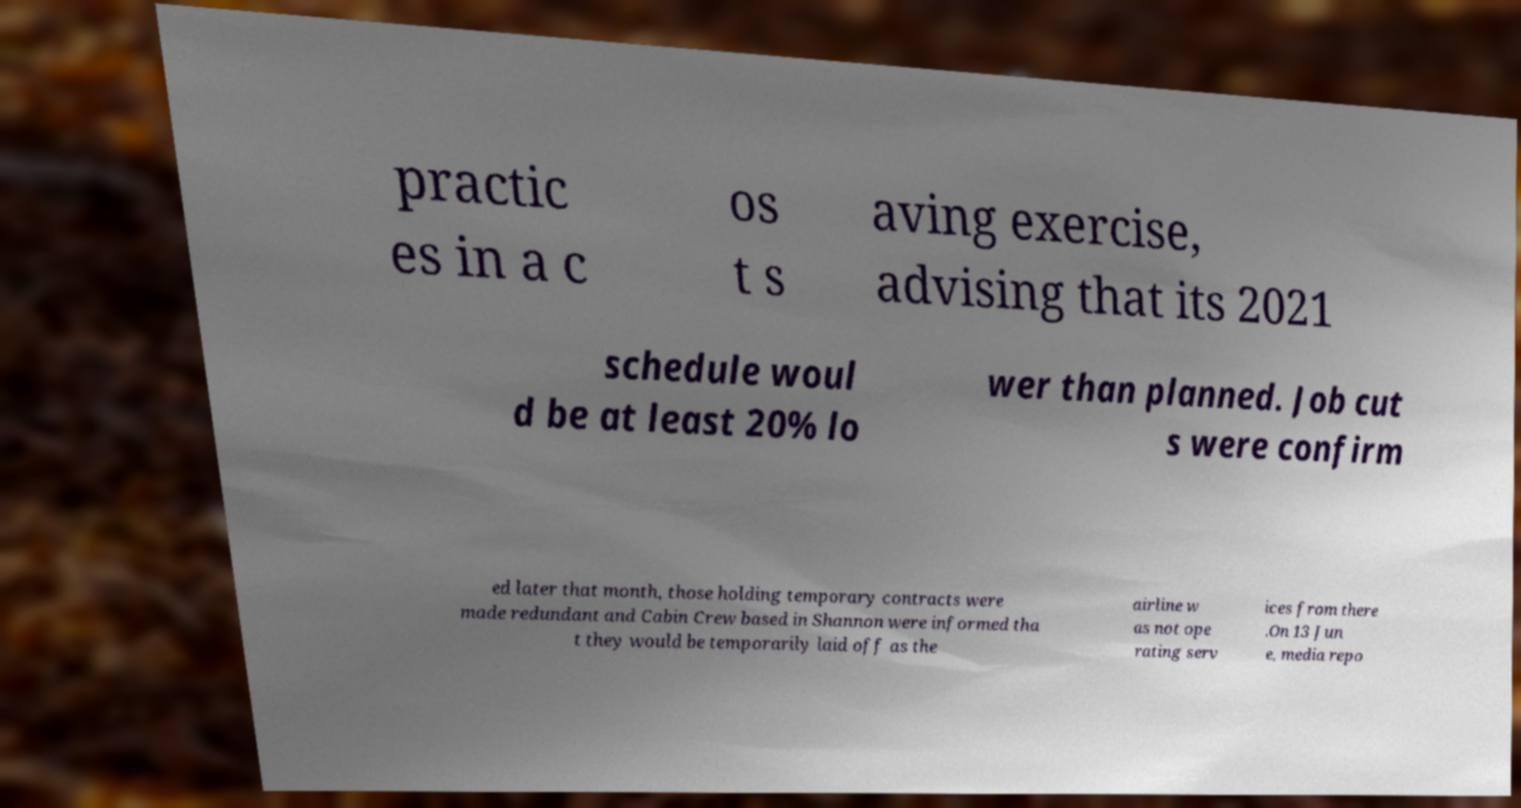There's text embedded in this image that I need extracted. Can you transcribe it verbatim? practic es in a c os t s aving exercise, advising that its 2021 schedule woul d be at least 20% lo wer than planned. Job cut s were confirm ed later that month, those holding temporary contracts were made redundant and Cabin Crew based in Shannon were informed tha t they would be temporarily laid off as the airline w as not ope rating serv ices from there .On 13 Jun e, media repo 